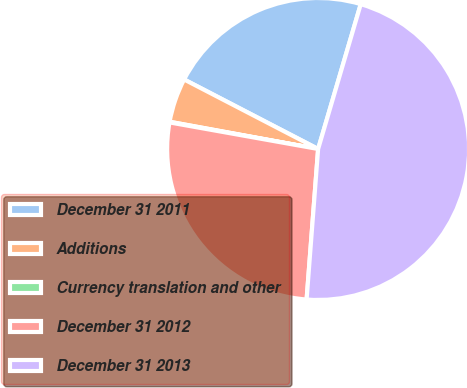Convert chart. <chart><loc_0><loc_0><loc_500><loc_500><pie_chart><fcel>December 31 2011<fcel>Additions<fcel>Currency translation and other<fcel>December 31 2012<fcel>December 31 2013<nl><fcel>21.94%<fcel>4.73%<fcel>0.07%<fcel>26.6%<fcel>46.66%<nl></chart> 